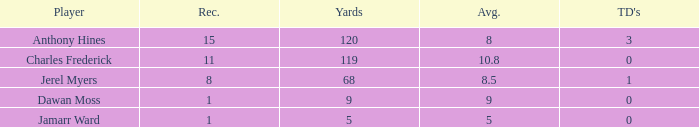What is the maximum number of touchdowns when the average is greater than 8.5 and the reception is below 1? None. 